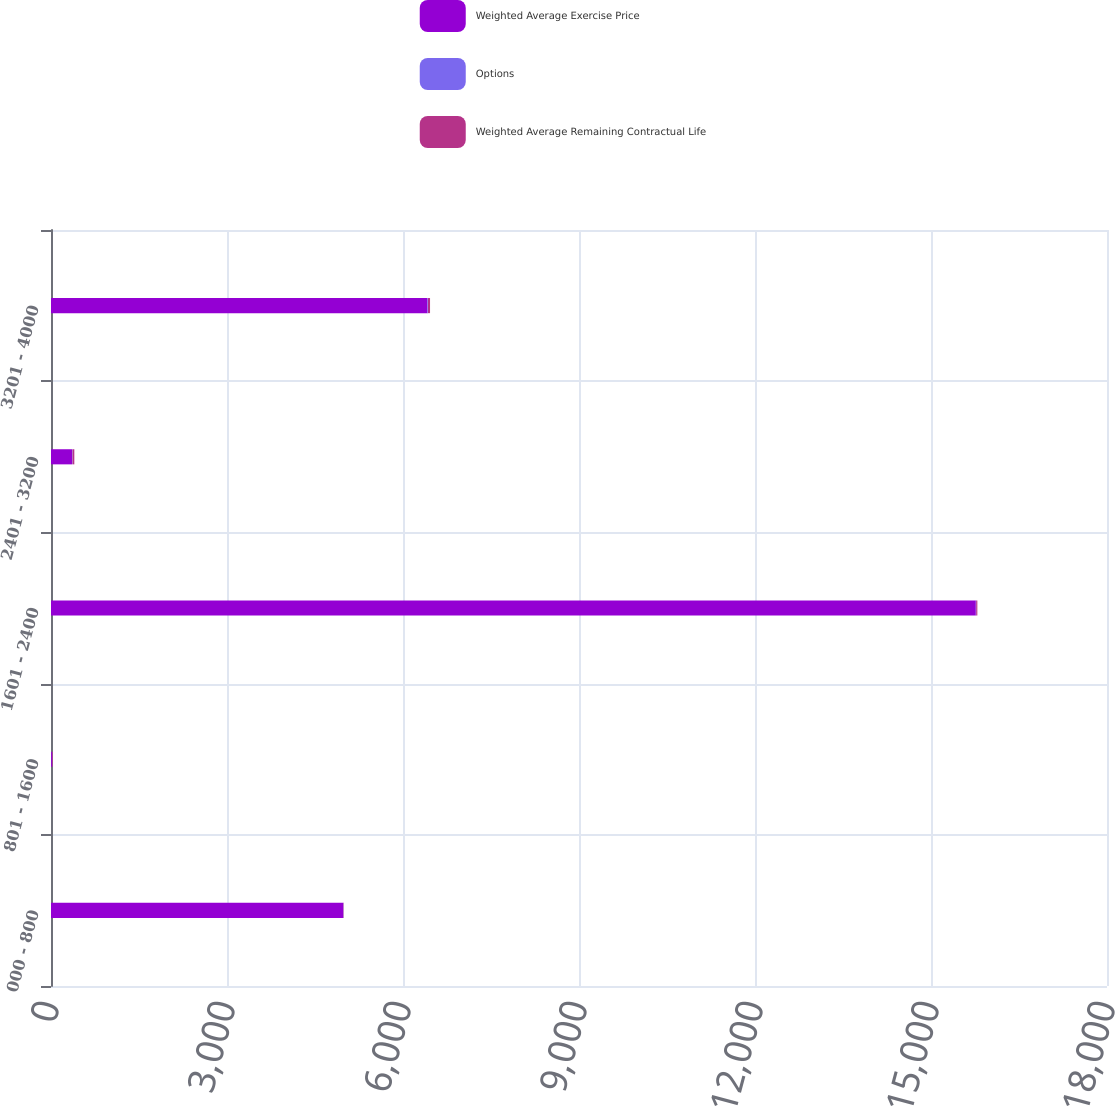Convert chart. <chart><loc_0><loc_0><loc_500><loc_500><stacked_bar_chart><ecel><fcel>000 - 800<fcel>801 - 1600<fcel>1601 - 2400<fcel>2401 - 3200<fcel>3201 - 4000<nl><fcel>Weighted Average Exercise Price<fcel>4980<fcel>15.845<fcel>15764<fcel>358<fcel>6417<nl><fcel>Options<fcel>5.14<fcel>5.15<fcel>6.2<fcel>8.57<fcel>9.01<nl><fcel>Weighted Average Remaining Contractual Life<fcel>6.37<fcel>11.87<fcel>19.82<fcel>31.02<fcel>34.85<nl></chart> 